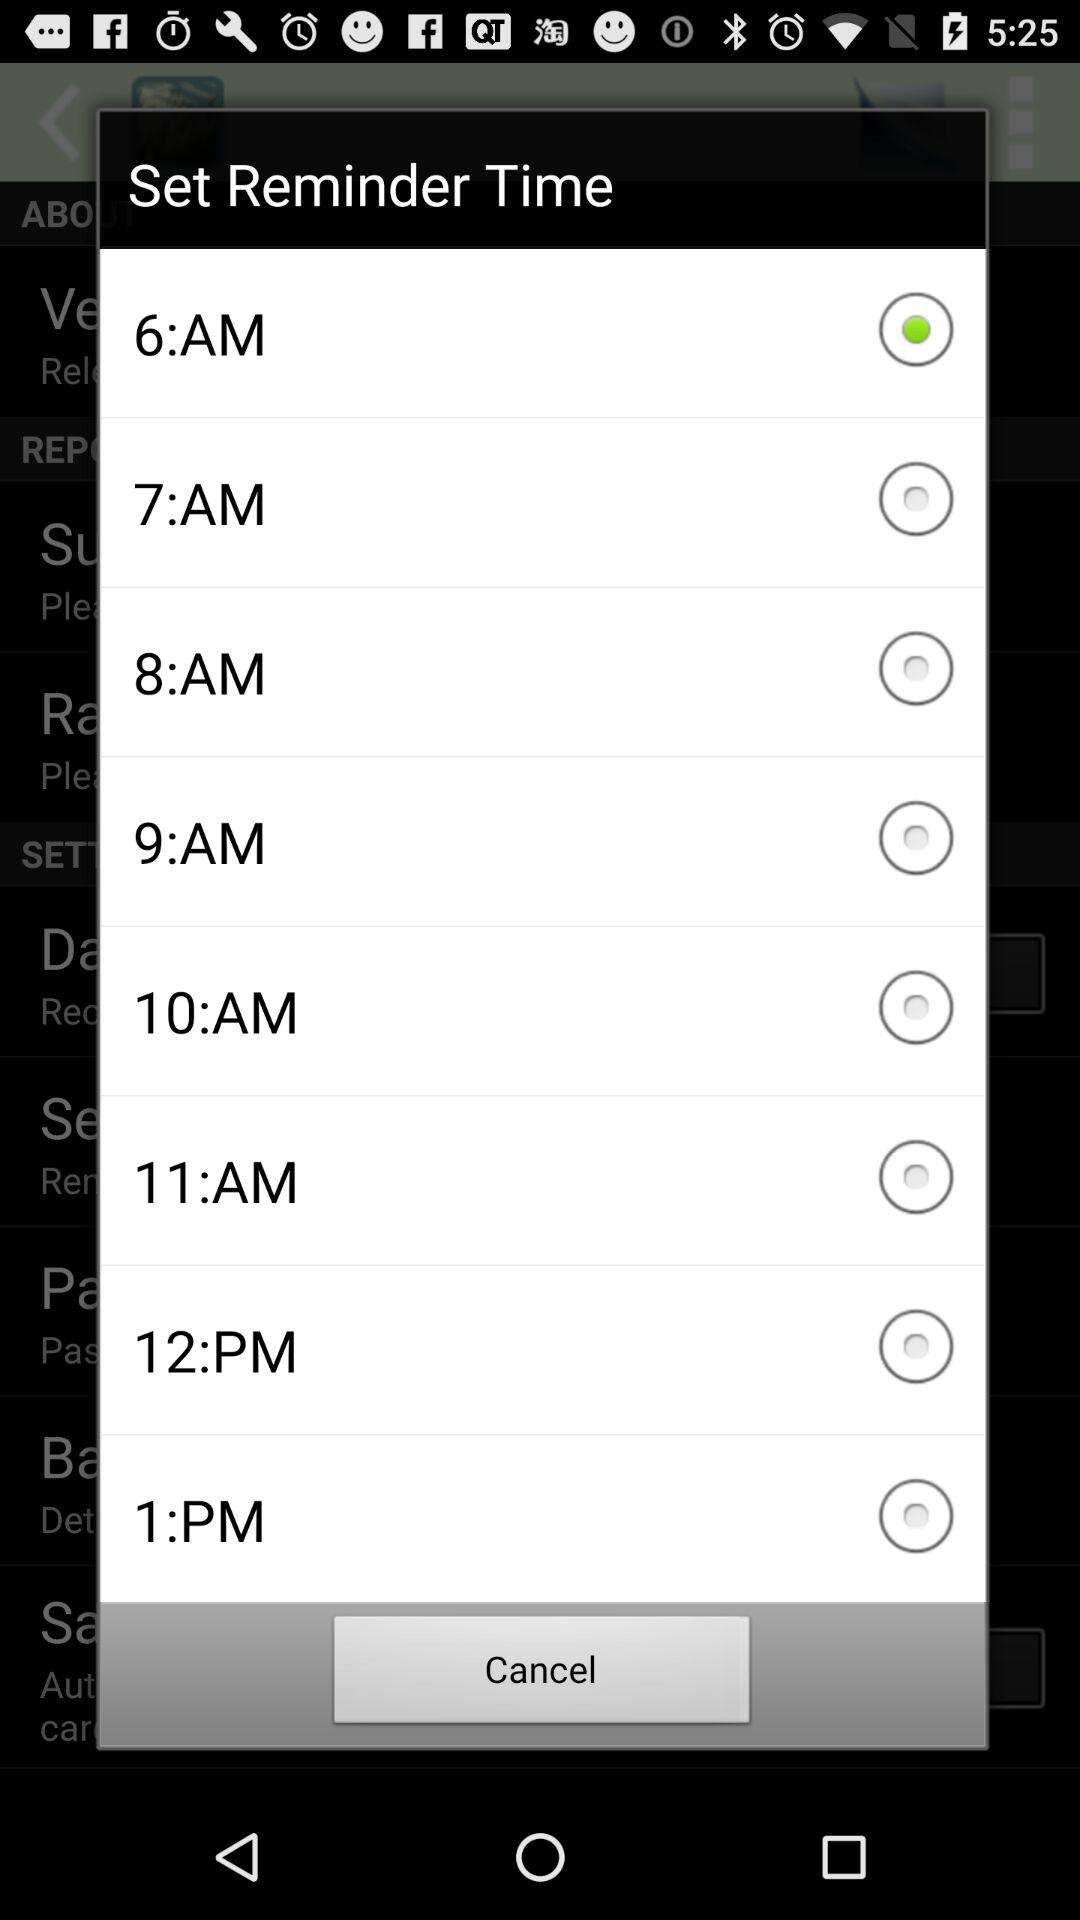What time is set for the reminder? The time is 6 AM. 